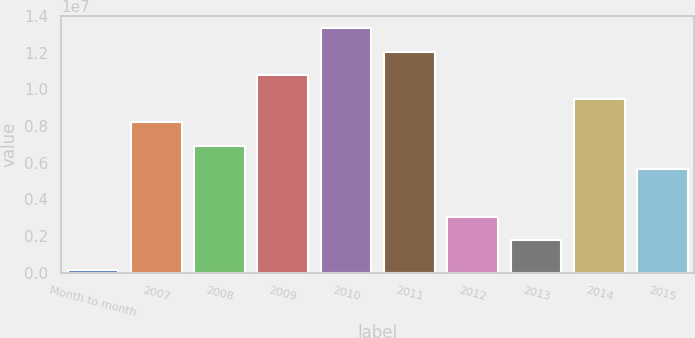Convert chart to OTSL. <chart><loc_0><loc_0><loc_500><loc_500><bar_chart><fcel>Month to month<fcel>2007<fcel>2008<fcel>2009<fcel>2010<fcel>2011<fcel>2012<fcel>2013<fcel>2014<fcel>2015<nl><fcel>149000<fcel>8.202e+06<fcel>6.9138e+06<fcel>1.07784e+07<fcel>1.33548e+07<fcel>1.20666e+07<fcel>3.0492e+06<fcel>1.761e+06<fcel>9.4902e+06<fcel>5.6256e+06<nl></chart> 